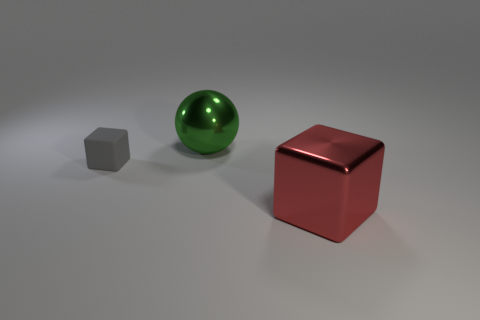Add 1 big purple metal things. How many objects exist? 4 Subtract all blocks. How many objects are left? 1 Subtract 0 brown cylinders. How many objects are left? 3 Subtract all big purple metal cubes. Subtract all tiny things. How many objects are left? 2 Add 3 small gray rubber things. How many small gray rubber things are left? 4 Add 1 large gray cylinders. How many large gray cylinders exist? 1 